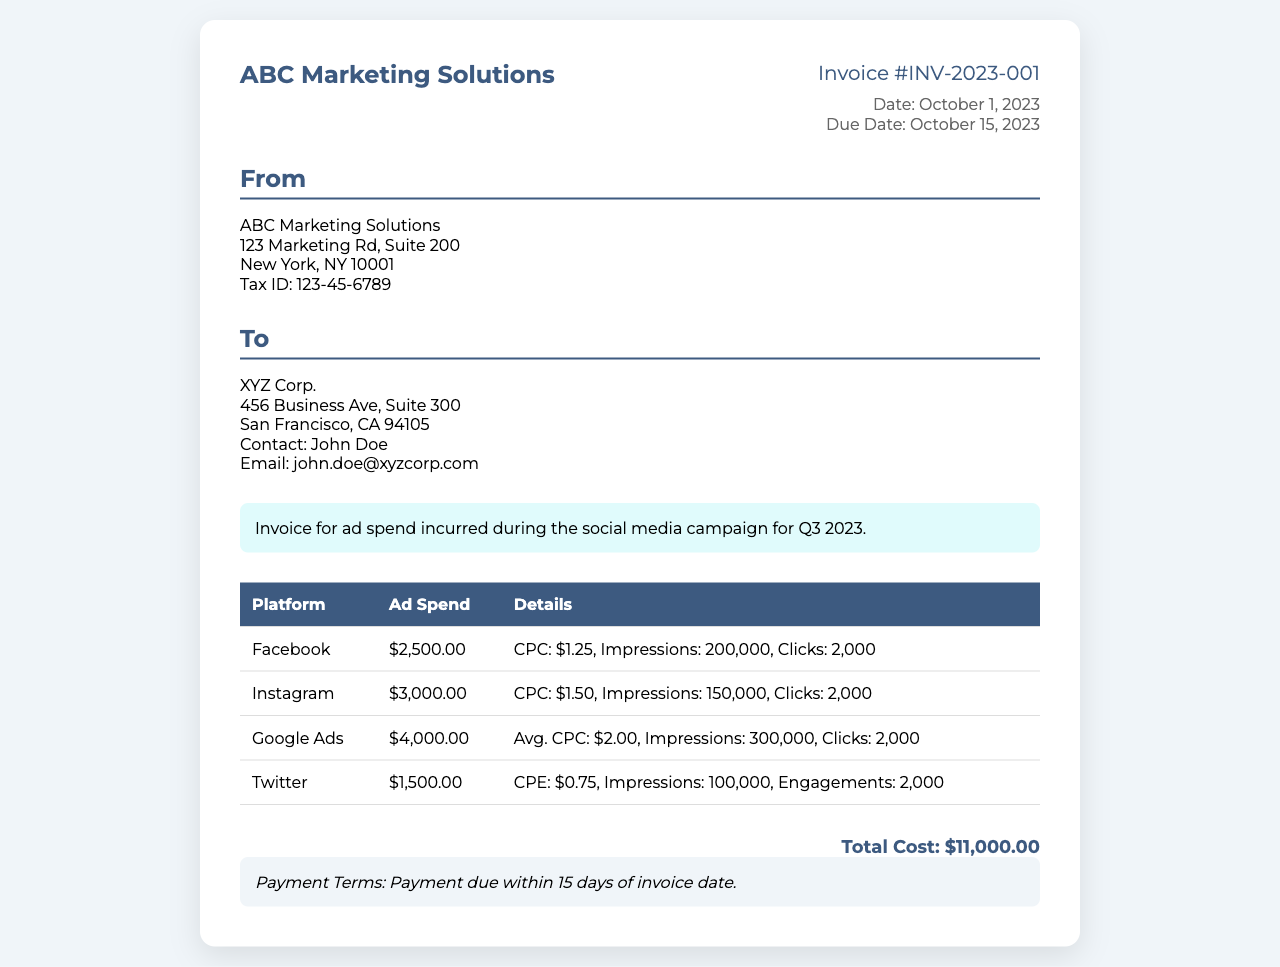What is the total cost of the invoice? The total cost is the sum of all ad spends listed for each platform, which is $2,500.00 + $3,000.00 + $4,000.00 + $1,500.00 = $11,000.00.
Answer: $11,000.00 What is the invoice number? The invoice number is provided at the top of the document, identified as Invoice #INV-2023-001.
Answer: Invoice #INV-2023-001 On which date is the invoice due? The due date is clearly stated in the document as October 15, 2023.
Answer: October 15, 2023 What platform had the highest ad spend? The platform with the highest ad spend is identified by examining the costs, which shows Google Ads had the largest expenditure of $4,000.00.
Answer: Google Ads How many impressions were received from Facebook ads? The number of impressions for Facebook is specified in the details section as 200,000.
Answer: 200,000 What is the contact person's name at XYZ Corp.? The contact person's name is mentioned in the client details section as John Doe.
Answer: John Doe What is the average cost per click on Instagram? The average cost per click for Instagram is detailed in the document as $1.50.
Answer: $1.50 What are the payment terms stated in the invoice? The payment terms outlined in the document indicate that payment is due within 15 days of the invoice date.
Answer: Payment due within 15 days What is the company name on the invoice? The company name is found at the top of the document, which states ABC Marketing Solutions.
Answer: ABC Marketing Solutions 